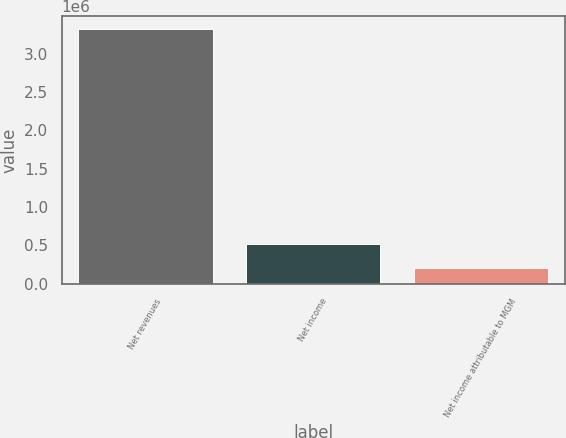Convert chart. <chart><loc_0><loc_0><loc_500><loc_500><bar_chart><fcel>Net revenues<fcel>Net income<fcel>Net income attributable to MGM<nl><fcel>3.31693e+06<fcel>521737<fcel>211160<nl></chart> 